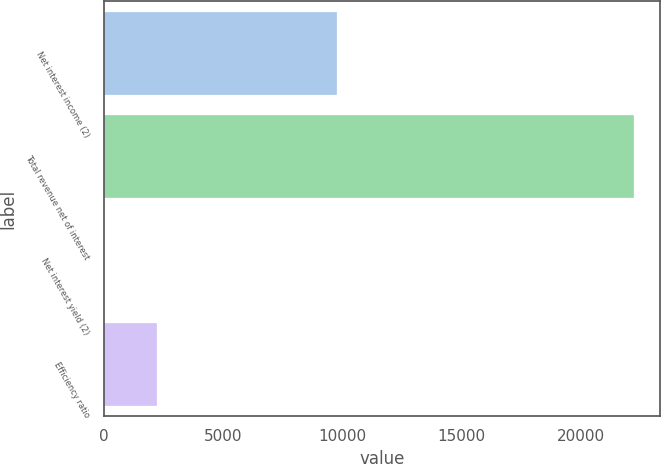Convert chart. <chart><loc_0><loc_0><loc_500><loc_500><bar_chart><fcel>Net interest income (2)<fcel>Total revenue net of interest<fcel>Net interest yield (2)<fcel>Efficiency ratio<nl><fcel>9782<fcel>22202<fcel>2.21<fcel>2222.19<nl></chart> 